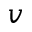Convert formula to latex. <formula><loc_0><loc_0><loc_500><loc_500>v</formula> 